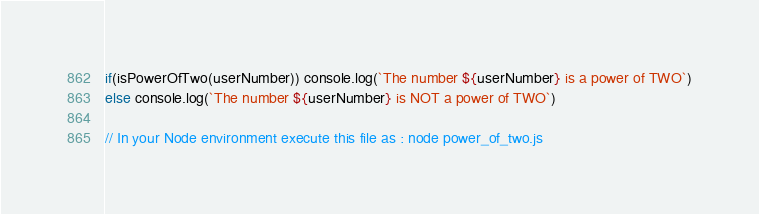<code> <loc_0><loc_0><loc_500><loc_500><_JavaScript_>
if(isPowerOfTwo(userNumber)) console.log(`The number ${userNumber} is a power of TWO`)
else console.log(`The number ${userNumber} is NOT a power of TWO`)

// In your Node environment execute this file as : node power_of_two.js
</code> 